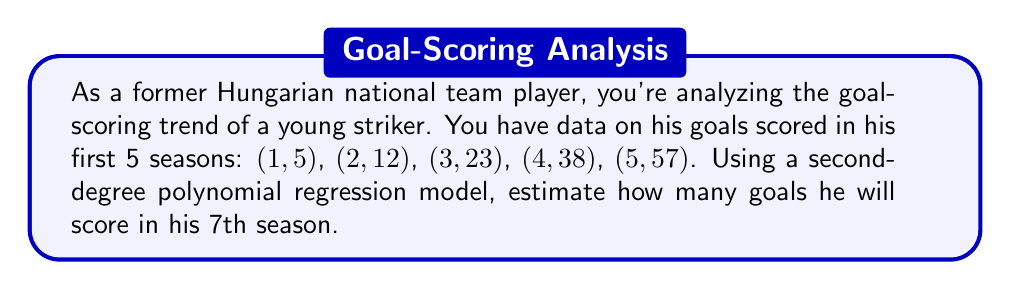What is the answer to this math problem? To solve this problem, we'll use a second-degree polynomial regression model of the form $y = ax^2 + bx + c$, where $y$ represents the number of goals and $x$ represents the season number.

1) First, we need to set up a system of equations using the given data points:
   $$5 = a(1)^2 + b(1) + c$$
   $$12 = a(2)^2 + b(2) + c$$
   $$23 = a(3)^2 + b(3) + c$$
   $$38 = a(4)^2 + b(4) + c$$
   $$57 = a(5)^2 + b(5) + c$$

2) We can solve this system using a matrix method or by using a calculator with regression capabilities. The result gives us:
   $a \approx 2.2$
   $b \approx -0.8$
   $c \approx 3.6$

3) Our regression equation is therefore:
   $$y = 2.2x^2 - 0.8x + 3.6$$

4) To estimate the number of goals in the 7th season, we substitute $x = 7$ into our equation:
   $$y = 2.2(7)^2 - 0.8(7) + 3.6$$
   $$y = 2.2(49) - 5.6 + 3.6$$
   $$y = 107.8 - 5.6 + 3.6$$
   $$y = 105.8$$

5) Since we're dealing with whole numbers of goals, we round to the nearest integer.
Answer: The estimated number of goals for the striker's 7th season is 106. 